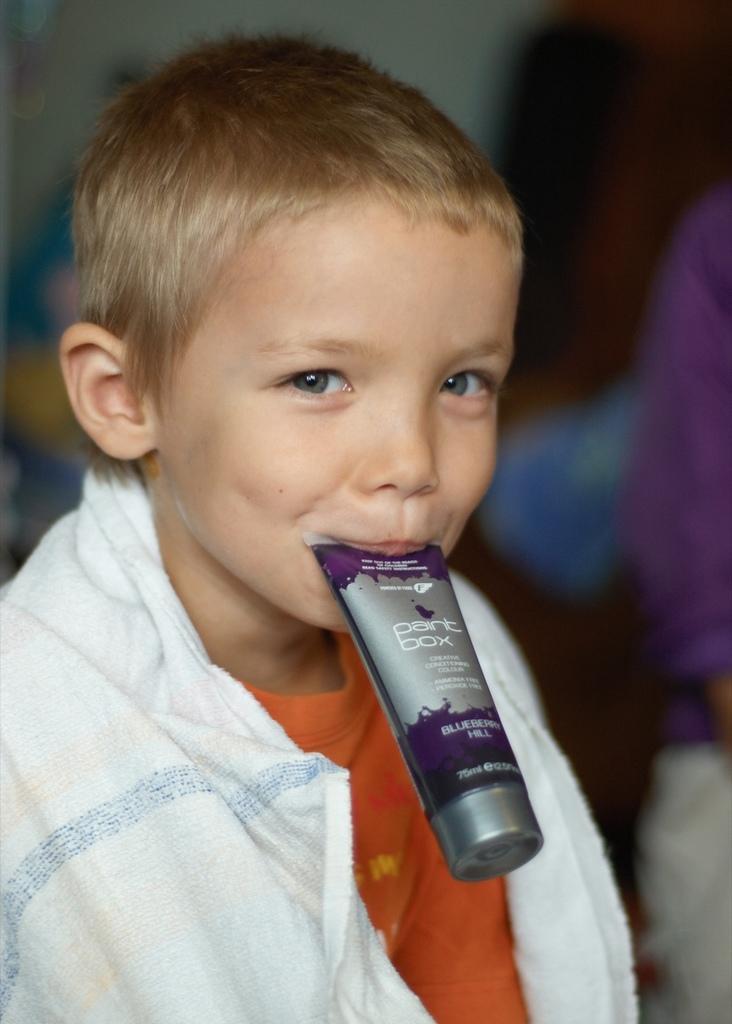Could you give a brief overview of what you see in this image? In this image there is a child placed a pack of cream in his mouth, beside him there is another person. The background is blurry. 